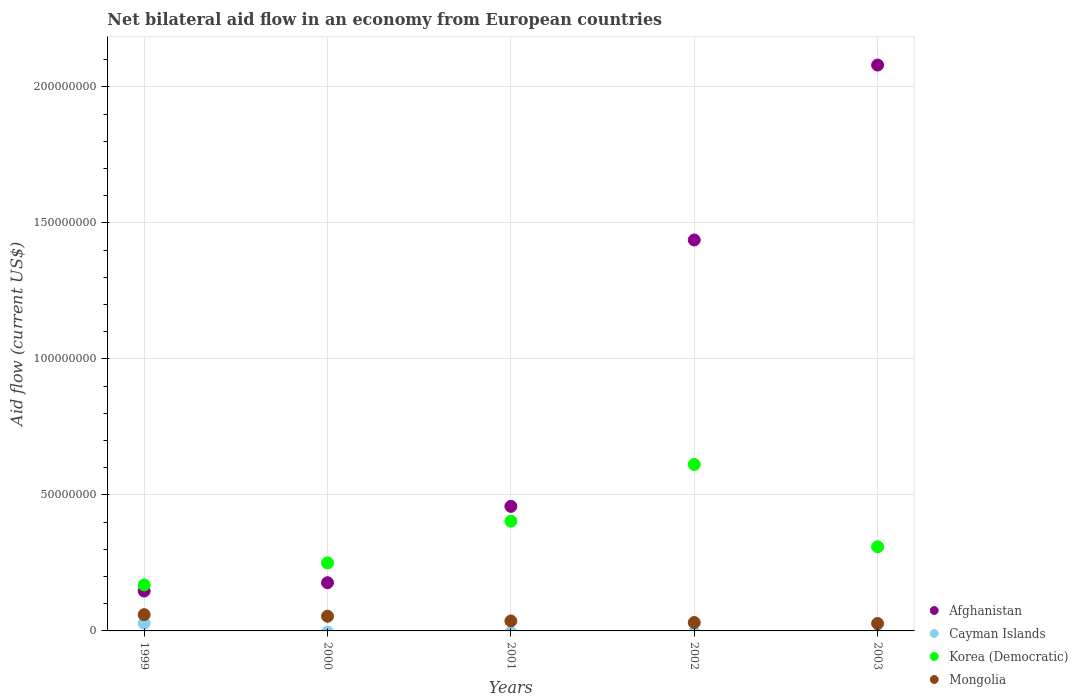What is the net bilateral aid flow in Korea (Democratic) in 2002?
Provide a succinct answer. 6.12e+07. Across all years, what is the maximum net bilateral aid flow in Cayman Islands?
Ensure brevity in your answer.  2.84e+06. Across all years, what is the minimum net bilateral aid flow in Mongolia?
Give a very brief answer. 2.74e+06. In which year was the net bilateral aid flow in Cayman Islands maximum?
Give a very brief answer. 1999. What is the total net bilateral aid flow in Afghanistan in the graph?
Your answer should be compact. 4.30e+08. What is the difference between the net bilateral aid flow in Afghanistan in 2001 and that in 2003?
Provide a succinct answer. -1.62e+08. What is the difference between the net bilateral aid flow in Afghanistan in 2002 and the net bilateral aid flow in Korea (Democratic) in 2001?
Keep it short and to the point. 1.03e+08. What is the average net bilateral aid flow in Afghanistan per year?
Keep it short and to the point. 8.60e+07. In the year 1999, what is the difference between the net bilateral aid flow in Cayman Islands and net bilateral aid flow in Korea (Democratic)?
Provide a short and direct response. -1.41e+07. In how many years, is the net bilateral aid flow in Cayman Islands greater than 90000000 US$?
Ensure brevity in your answer.  0. What is the ratio of the net bilateral aid flow in Mongolia in 2000 to that in 2003?
Make the answer very short. 1.97. What is the difference between the highest and the second highest net bilateral aid flow in Mongolia?
Give a very brief answer. 5.90e+05. What is the difference between the highest and the lowest net bilateral aid flow in Mongolia?
Your response must be concise. 3.25e+06. In how many years, is the net bilateral aid flow in Mongolia greater than the average net bilateral aid flow in Mongolia taken over all years?
Ensure brevity in your answer.  2. Is the sum of the net bilateral aid flow in Afghanistan in 2001 and 2003 greater than the maximum net bilateral aid flow in Korea (Democratic) across all years?
Your answer should be very brief. Yes. Is it the case that in every year, the sum of the net bilateral aid flow in Afghanistan and net bilateral aid flow in Korea (Democratic)  is greater than the net bilateral aid flow in Mongolia?
Make the answer very short. Yes. Does the net bilateral aid flow in Korea (Democratic) monotonically increase over the years?
Provide a short and direct response. No. Is the net bilateral aid flow in Korea (Democratic) strictly greater than the net bilateral aid flow in Cayman Islands over the years?
Make the answer very short. Yes. How many dotlines are there?
Your response must be concise. 4. Does the graph contain any zero values?
Give a very brief answer. Yes. Does the graph contain grids?
Ensure brevity in your answer.  Yes. Where does the legend appear in the graph?
Give a very brief answer. Bottom right. How many legend labels are there?
Your answer should be compact. 4. What is the title of the graph?
Offer a very short reply. Net bilateral aid flow in an economy from European countries. What is the label or title of the Y-axis?
Make the answer very short. Aid flow (current US$). What is the Aid flow (current US$) in Afghanistan in 1999?
Provide a succinct answer. 1.47e+07. What is the Aid flow (current US$) in Cayman Islands in 1999?
Your response must be concise. 2.84e+06. What is the Aid flow (current US$) in Korea (Democratic) in 1999?
Offer a terse response. 1.69e+07. What is the Aid flow (current US$) of Mongolia in 1999?
Offer a terse response. 5.99e+06. What is the Aid flow (current US$) in Afghanistan in 2000?
Provide a short and direct response. 1.77e+07. What is the Aid flow (current US$) of Cayman Islands in 2000?
Provide a succinct answer. 0. What is the Aid flow (current US$) of Korea (Democratic) in 2000?
Keep it short and to the point. 2.50e+07. What is the Aid flow (current US$) in Mongolia in 2000?
Provide a short and direct response. 5.40e+06. What is the Aid flow (current US$) in Afghanistan in 2001?
Provide a succinct answer. 4.58e+07. What is the Aid flow (current US$) of Korea (Democratic) in 2001?
Give a very brief answer. 4.03e+07. What is the Aid flow (current US$) in Mongolia in 2001?
Offer a terse response. 3.66e+06. What is the Aid flow (current US$) of Afghanistan in 2002?
Your response must be concise. 1.44e+08. What is the Aid flow (current US$) in Korea (Democratic) in 2002?
Ensure brevity in your answer.  6.12e+07. What is the Aid flow (current US$) in Mongolia in 2002?
Provide a succinct answer. 3.08e+06. What is the Aid flow (current US$) in Afghanistan in 2003?
Your answer should be compact. 2.08e+08. What is the Aid flow (current US$) in Cayman Islands in 2003?
Your answer should be very brief. 0. What is the Aid flow (current US$) in Korea (Democratic) in 2003?
Your answer should be very brief. 3.09e+07. What is the Aid flow (current US$) of Mongolia in 2003?
Your answer should be very brief. 2.74e+06. Across all years, what is the maximum Aid flow (current US$) in Afghanistan?
Your answer should be compact. 2.08e+08. Across all years, what is the maximum Aid flow (current US$) in Cayman Islands?
Provide a short and direct response. 2.84e+06. Across all years, what is the maximum Aid flow (current US$) of Korea (Democratic)?
Ensure brevity in your answer.  6.12e+07. Across all years, what is the maximum Aid flow (current US$) of Mongolia?
Offer a terse response. 5.99e+06. Across all years, what is the minimum Aid flow (current US$) in Afghanistan?
Your answer should be compact. 1.47e+07. Across all years, what is the minimum Aid flow (current US$) in Cayman Islands?
Give a very brief answer. 0. Across all years, what is the minimum Aid flow (current US$) in Korea (Democratic)?
Your answer should be very brief. 1.69e+07. Across all years, what is the minimum Aid flow (current US$) of Mongolia?
Give a very brief answer. 2.74e+06. What is the total Aid flow (current US$) in Afghanistan in the graph?
Your answer should be compact. 4.30e+08. What is the total Aid flow (current US$) of Cayman Islands in the graph?
Keep it short and to the point. 2.84e+06. What is the total Aid flow (current US$) in Korea (Democratic) in the graph?
Make the answer very short. 1.74e+08. What is the total Aid flow (current US$) of Mongolia in the graph?
Offer a terse response. 2.09e+07. What is the difference between the Aid flow (current US$) of Afghanistan in 1999 and that in 2000?
Offer a terse response. -3.06e+06. What is the difference between the Aid flow (current US$) of Korea (Democratic) in 1999 and that in 2000?
Your response must be concise. -8.10e+06. What is the difference between the Aid flow (current US$) in Mongolia in 1999 and that in 2000?
Your answer should be very brief. 5.90e+05. What is the difference between the Aid flow (current US$) of Afghanistan in 1999 and that in 2001?
Make the answer very short. -3.11e+07. What is the difference between the Aid flow (current US$) of Korea (Democratic) in 1999 and that in 2001?
Ensure brevity in your answer.  -2.34e+07. What is the difference between the Aid flow (current US$) in Mongolia in 1999 and that in 2001?
Keep it short and to the point. 2.33e+06. What is the difference between the Aid flow (current US$) in Afghanistan in 1999 and that in 2002?
Offer a terse response. -1.29e+08. What is the difference between the Aid flow (current US$) of Korea (Democratic) in 1999 and that in 2002?
Provide a succinct answer. -4.43e+07. What is the difference between the Aid flow (current US$) of Mongolia in 1999 and that in 2002?
Your answer should be compact. 2.91e+06. What is the difference between the Aid flow (current US$) of Afghanistan in 1999 and that in 2003?
Offer a terse response. -1.93e+08. What is the difference between the Aid flow (current US$) in Korea (Democratic) in 1999 and that in 2003?
Give a very brief answer. -1.40e+07. What is the difference between the Aid flow (current US$) of Mongolia in 1999 and that in 2003?
Give a very brief answer. 3.25e+06. What is the difference between the Aid flow (current US$) of Afghanistan in 2000 and that in 2001?
Provide a succinct answer. -2.81e+07. What is the difference between the Aid flow (current US$) of Korea (Democratic) in 2000 and that in 2001?
Offer a very short reply. -1.53e+07. What is the difference between the Aid flow (current US$) in Mongolia in 2000 and that in 2001?
Your answer should be compact. 1.74e+06. What is the difference between the Aid flow (current US$) in Afghanistan in 2000 and that in 2002?
Provide a succinct answer. -1.26e+08. What is the difference between the Aid flow (current US$) of Korea (Democratic) in 2000 and that in 2002?
Provide a short and direct response. -3.62e+07. What is the difference between the Aid flow (current US$) in Mongolia in 2000 and that in 2002?
Your answer should be very brief. 2.32e+06. What is the difference between the Aid flow (current US$) in Afghanistan in 2000 and that in 2003?
Provide a succinct answer. -1.90e+08. What is the difference between the Aid flow (current US$) in Korea (Democratic) in 2000 and that in 2003?
Ensure brevity in your answer.  -5.92e+06. What is the difference between the Aid flow (current US$) in Mongolia in 2000 and that in 2003?
Your answer should be compact. 2.66e+06. What is the difference between the Aid flow (current US$) in Afghanistan in 2001 and that in 2002?
Provide a short and direct response. -9.79e+07. What is the difference between the Aid flow (current US$) in Korea (Democratic) in 2001 and that in 2002?
Offer a terse response. -2.09e+07. What is the difference between the Aid flow (current US$) in Mongolia in 2001 and that in 2002?
Give a very brief answer. 5.80e+05. What is the difference between the Aid flow (current US$) of Afghanistan in 2001 and that in 2003?
Keep it short and to the point. -1.62e+08. What is the difference between the Aid flow (current US$) of Korea (Democratic) in 2001 and that in 2003?
Your response must be concise. 9.41e+06. What is the difference between the Aid flow (current US$) of Mongolia in 2001 and that in 2003?
Ensure brevity in your answer.  9.20e+05. What is the difference between the Aid flow (current US$) in Afghanistan in 2002 and that in 2003?
Offer a very short reply. -6.43e+07. What is the difference between the Aid flow (current US$) of Korea (Democratic) in 2002 and that in 2003?
Offer a terse response. 3.03e+07. What is the difference between the Aid flow (current US$) in Mongolia in 2002 and that in 2003?
Your answer should be compact. 3.40e+05. What is the difference between the Aid flow (current US$) in Afghanistan in 1999 and the Aid flow (current US$) in Korea (Democratic) in 2000?
Your answer should be very brief. -1.03e+07. What is the difference between the Aid flow (current US$) in Afghanistan in 1999 and the Aid flow (current US$) in Mongolia in 2000?
Offer a terse response. 9.27e+06. What is the difference between the Aid flow (current US$) in Cayman Islands in 1999 and the Aid flow (current US$) in Korea (Democratic) in 2000?
Offer a terse response. -2.22e+07. What is the difference between the Aid flow (current US$) in Cayman Islands in 1999 and the Aid flow (current US$) in Mongolia in 2000?
Your response must be concise. -2.56e+06. What is the difference between the Aid flow (current US$) of Korea (Democratic) in 1999 and the Aid flow (current US$) of Mongolia in 2000?
Your answer should be very brief. 1.15e+07. What is the difference between the Aid flow (current US$) in Afghanistan in 1999 and the Aid flow (current US$) in Korea (Democratic) in 2001?
Make the answer very short. -2.57e+07. What is the difference between the Aid flow (current US$) in Afghanistan in 1999 and the Aid flow (current US$) in Mongolia in 2001?
Make the answer very short. 1.10e+07. What is the difference between the Aid flow (current US$) of Cayman Islands in 1999 and the Aid flow (current US$) of Korea (Democratic) in 2001?
Your answer should be very brief. -3.75e+07. What is the difference between the Aid flow (current US$) of Cayman Islands in 1999 and the Aid flow (current US$) of Mongolia in 2001?
Offer a terse response. -8.20e+05. What is the difference between the Aid flow (current US$) of Korea (Democratic) in 1999 and the Aid flow (current US$) of Mongolia in 2001?
Keep it short and to the point. 1.32e+07. What is the difference between the Aid flow (current US$) of Afghanistan in 1999 and the Aid flow (current US$) of Korea (Democratic) in 2002?
Offer a very short reply. -4.65e+07. What is the difference between the Aid flow (current US$) in Afghanistan in 1999 and the Aid flow (current US$) in Mongolia in 2002?
Make the answer very short. 1.16e+07. What is the difference between the Aid flow (current US$) of Cayman Islands in 1999 and the Aid flow (current US$) of Korea (Democratic) in 2002?
Make the answer very short. -5.84e+07. What is the difference between the Aid flow (current US$) in Cayman Islands in 1999 and the Aid flow (current US$) in Mongolia in 2002?
Provide a succinct answer. -2.40e+05. What is the difference between the Aid flow (current US$) of Korea (Democratic) in 1999 and the Aid flow (current US$) of Mongolia in 2002?
Provide a short and direct response. 1.38e+07. What is the difference between the Aid flow (current US$) of Afghanistan in 1999 and the Aid flow (current US$) of Korea (Democratic) in 2003?
Make the answer very short. -1.63e+07. What is the difference between the Aid flow (current US$) in Afghanistan in 1999 and the Aid flow (current US$) in Mongolia in 2003?
Offer a terse response. 1.19e+07. What is the difference between the Aid flow (current US$) of Cayman Islands in 1999 and the Aid flow (current US$) of Korea (Democratic) in 2003?
Your answer should be very brief. -2.81e+07. What is the difference between the Aid flow (current US$) in Cayman Islands in 1999 and the Aid flow (current US$) in Mongolia in 2003?
Your response must be concise. 1.00e+05. What is the difference between the Aid flow (current US$) of Korea (Democratic) in 1999 and the Aid flow (current US$) of Mongolia in 2003?
Your answer should be compact. 1.42e+07. What is the difference between the Aid flow (current US$) of Afghanistan in 2000 and the Aid flow (current US$) of Korea (Democratic) in 2001?
Offer a very short reply. -2.26e+07. What is the difference between the Aid flow (current US$) of Afghanistan in 2000 and the Aid flow (current US$) of Mongolia in 2001?
Your answer should be very brief. 1.41e+07. What is the difference between the Aid flow (current US$) of Korea (Democratic) in 2000 and the Aid flow (current US$) of Mongolia in 2001?
Ensure brevity in your answer.  2.14e+07. What is the difference between the Aid flow (current US$) of Afghanistan in 2000 and the Aid flow (current US$) of Korea (Democratic) in 2002?
Provide a short and direct response. -4.35e+07. What is the difference between the Aid flow (current US$) in Afghanistan in 2000 and the Aid flow (current US$) in Mongolia in 2002?
Your answer should be compact. 1.46e+07. What is the difference between the Aid flow (current US$) of Korea (Democratic) in 2000 and the Aid flow (current US$) of Mongolia in 2002?
Provide a short and direct response. 2.19e+07. What is the difference between the Aid flow (current US$) of Afghanistan in 2000 and the Aid flow (current US$) of Korea (Democratic) in 2003?
Keep it short and to the point. -1.32e+07. What is the difference between the Aid flow (current US$) in Afghanistan in 2000 and the Aid flow (current US$) in Mongolia in 2003?
Make the answer very short. 1.50e+07. What is the difference between the Aid flow (current US$) of Korea (Democratic) in 2000 and the Aid flow (current US$) of Mongolia in 2003?
Provide a succinct answer. 2.23e+07. What is the difference between the Aid flow (current US$) of Afghanistan in 2001 and the Aid flow (current US$) of Korea (Democratic) in 2002?
Offer a terse response. -1.54e+07. What is the difference between the Aid flow (current US$) in Afghanistan in 2001 and the Aid flow (current US$) in Mongolia in 2002?
Provide a short and direct response. 4.27e+07. What is the difference between the Aid flow (current US$) in Korea (Democratic) in 2001 and the Aid flow (current US$) in Mongolia in 2002?
Your answer should be compact. 3.73e+07. What is the difference between the Aid flow (current US$) in Afghanistan in 2001 and the Aid flow (current US$) in Korea (Democratic) in 2003?
Offer a very short reply. 1.49e+07. What is the difference between the Aid flow (current US$) of Afghanistan in 2001 and the Aid flow (current US$) of Mongolia in 2003?
Your response must be concise. 4.30e+07. What is the difference between the Aid flow (current US$) of Korea (Democratic) in 2001 and the Aid flow (current US$) of Mongolia in 2003?
Offer a terse response. 3.76e+07. What is the difference between the Aid flow (current US$) in Afghanistan in 2002 and the Aid flow (current US$) in Korea (Democratic) in 2003?
Provide a short and direct response. 1.13e+08. What is the difference between the Aid flow (current US$) in Afghanistan in 2002 and the Aid flow (current US$) in Mongolia in 2003?
Your answer should be very brief. 1.41e+08. What is the difference between the Aid flow (current US$) of Korea (Democratic) in 2002 and the Aid flow (current US$) of Mongolia in 2003?
Provide a short and direct response. 5.85e+07. What is the average Aid flow (current US$) of Afghanistan per year?
Ensure brevity in your answer.  8.60e+07. What is the average Aid flow (current US$) in Cayman Islands per year?
Your answer should be compact. 5.68e+05. What is the average Aid flow (current US$) in Korea (Democratic) per year?
Make the answer very short. 3.49e+07. What is the average Aid flow (current US$) of Mongolia per year?
Your answer should be very brief. 4.17e+06. In the year 1999, what is the difference between the Aid flow (current US$) in Afghanistan and Aid flow (current US$) in Cayman Islands?
Give a very brief answer. 1.18e+07. In the year 1999, what is the difference between the Aid flow (current US$) in Afghanistan and Aid flow (current US$) in Korea (Democratic)?
Give a very brief answer. -2.24e+06. In the year 1999, what is the difference between the Aid flow (current US$) in Afghanistan and Aid flow (current US$) in Mongolia?
Provide a short and direct response. 8.68e+06. In the year 1999, what is the difference between the Aid flow (current US$) in Cayman Islands and Aid flow (current US$) in Korea (Democratic)?
Your answer should be very brief. -1.41e+07. In the year 1999, what is the difference between the Aid flow (current US$) of Cayman Islands and Aid flow (current US$) of Mongolia?
Your response must be concise. -3.15e+06. In the year 1999, what is the difference between the Aid flow (current US$) of Korea (Democratic) and Aid flow (current US$) of Mongolia?
Make the answer very short. 1.09e+07. In the year 2000, what is the difference between the Aid flow (current US$) in Afghanistan and Aid flow (current US$) in Korea (Democratic)?
Your response must be concise. -7.28e+06. In the year 2000, what is the difference between the Aid flow (current US$) in Afghanistan and Aid flow (current US$) in Mongolia?
Your answer should be compact. 1.23e+07. In the year 2000, what is the difference between the Aid flow (current US$) of Korea (Democratic) and Aid flow (current US$) of Mongolia?
Offer a terse response. 1.96e+07. In the year 2001, what is the difference between the Aid flow (current US$) of Afghanistan and Aid flow (current US$) of Korea (Democratic)?
Ensure brevity in your answer.  5.45e+06. In the year 2001, what is the difference between the Aid flow (current US$) of Afghanistan and Aid flow (current US$) of Mongolia?
Your answer should be compact. 4.21e+07. In the year 2001, what is the difference between the Aid flow (current US$) in Korea (Democratic) and Aid flow (current US$) in Mongolia?
Give a very brief answer. 3.67e+07. In the year 2002, what is the difference between the Aid flow (current US$) of Afghanistan and Aid flow (current US$) of Korea (Democratic)?
Provide a short and direct response. 8.25e+07. In the year 2002, what is the difference between the Aid flow (current US$) of Afghanistan and Aid flow (current US$) of Mongolia?
Your answer should be compact. 1.41e+08. In the year 2002, what is the difference between the Aid flow (current US$) in Korea (Democratic) and Aid flow (current US$) in Mongolia?
Make the answer very short. 5.81e+07. In the year 2003, what is the difference between the Aid flow (current US$) of Afghanistan and Aid flow (current US$) of Korea (Democratic)?
Offer a very short reply. 1.77e+08. In the year 2003, what is the difference between the Aid flow (current US$) in Afghanistan and Aid flow (current US$) in Mongolia?
Your response must be concise. 2.05e+08. In the year 2003, what is the difference between the Aid flow (current US$) in Korea (Democratic) and Aid flow (current US$) in Mongolia?
Offer a terse response. 2.82e+07. What is the ratio of the Aid flow (current US$) in Afghanistan in 1999 to that in 2000?
Your answer should be compact. 0.83. What is the ratio of the Aid flow (current US$) of Korea (Democratic) in 1999 to that in 2000?
Keep it short and to the point. 0.68. What is the ratio of the Aid flow (current US$) in Mongolia in 1999 to that in 2000?
Your answer should be very brief. 1.11. What is the ratio of the Aid flow (current US$) of Afghanistan in 1999 to that in 2001?
Offer a terse response. 0.32. What is the ratio of the Aid flow (current US$) in Korea (Democratic) in 1999 to that in 2001?
Your answer should be compact. 0.42. What is the ratio of the Aid flow (current US$) of Mongolia in 1999 to that in 2001?
Give a very brief answer. 1.64. What is the ratio of the Aid flow (current US$) of Afghanistan in 1999 to that in 2002?
Offer a terse response. 0.1. What is the ratio of the Aid flow (current US$) of Korea (Democratic) in 1999 to that in 2002?
Your answer should be compact. 0.28. What is the ratio of the Aid flow (current US$) of Mongolia in 1999 to that in 2002?
Provide a short and direct response. 1.94. What is the ratio of the Aid flow (current US$) of Afghanistan in 1999 to that in 2003?
Give a very brief answer. 0.07. What is the ratio of the Aid flow (current US$) in Korea (Democratic) in 1999 to that in 2003?
Your response must be concise. 0.55. What is the ratio of the Aid flow (current US$) in Mongolia in 1999 to that in 2003?
Keep it short and to the point. 2.19. What is the ratio of the Aid flow (current US$) of Afghanistan in 2000 to that in 2001?
Provide a succinct answer. 0.39. What is the ratio of the Aid flow (current US$) of Korea (Democratic) in 2000 to that in 2001?
Your answer should be very brief. 0.62. What is the ratio of the Aid flow (current US$) in Mongolia in 2000 to that in 2001?
Your answer should be very brief. 1.48. What is the ratio of the Aid flow (current US$) of Afghanistan in 2000 to that in 2002?
Give a very brief answer. 0.12. What is the ratio of the Aid flow (current US$) of Korea (Democratic) in 2000 to that in 2002?
Make the answer very short. 0.41. What is the ratio of the Aid flow (current US$) in Mongolia in 2000 to that in 2002?
Ensure brevity in your answer.  1.75. What is the ratio of the Aid flow (current US$) in Afghanistan in 2000 to that in 2003?
Make the answer very short. 0.09. What is the ratio of the Aid flow (current US$) in Korea (Democratic) in 2000 to that in 2003?
Offer a very short reply. 0.81. What is the ratio of the Aid flow (current US$) of Mongolia in 2000 to that in 2003?
Ensure brevity in your answer.  1.97. What is the ratio of the Aid flow (current US$) of Afghanistan in 2001 to that in 2002?
Your answer should be very brief. 0.32. What is the ratio of the Aid flow (current US$) in Korea (Democratic) in 2001 to that in 2002?
Offer a terse response. 0.66. What is the ratio of the Aid flow (current US$) in Mongolia in 2001 to that in 2002?
Provide a succinct answer. 1.19. What is the ratio of the Aid flow (current US$) of Afghanistan in 2001 to that in 2003?
Make the answer very short. 0.22. What is the ratio of the Aid flow (current US$) in Korea (Democratic) in 2001 to that in 2003?
Keep it short and to the point. 1.3. What is the ratio of the Aid flow (current US$) in Mongolia in 2001 to that in 2003?
Provide a short and direct response. 1.34. What is the ratio of the Aid flow (current US$) in Afghanistan in 2002 to that in 2003?
Offer a very short reply. 0.69. What is the ratio of the Aid flow (current US$) of Korea (Democratic) in 2002 to that in 2003?
Give a very brief answer. 1.98. What is the ratio of the Aid flow (current US$) in Mongolia in 2002 to that in 2003?
Keep it short and to the point. 1.12. What is the difference between the highest and the second highest Aid flow (current US$) in Afghanistan?
Make the answer very short. 6.43e+07. What is the difference between the highest and the second highest Aid flow (current US$) in Korea (Democratic)?
Provide a succinct answer. 2.09e+07. What is the difference between the highest and the second highest Aid flow (current US$) of Mongolia?
Give a very brief answer. 5.90e+05. What is the difference between the highest and the lowest Aid flow (current US$) in Afghanistan?
Offer a terse response. 1.93e+08. What is the difference between the highest and the lowest Aid flow (current US$) in Cayman Islands?
Ensure brevity in your answer.  2.84e+06. What is the difference between the highest and the lowest Aid flow (current US$) in Korea (Democratic)?
Your answer should be compact. 4.43e+07. What is the difference between the highest and the lowest Aid flow (current US$) of Mongolia?
Offer a very short reply. 3.25e+06. 